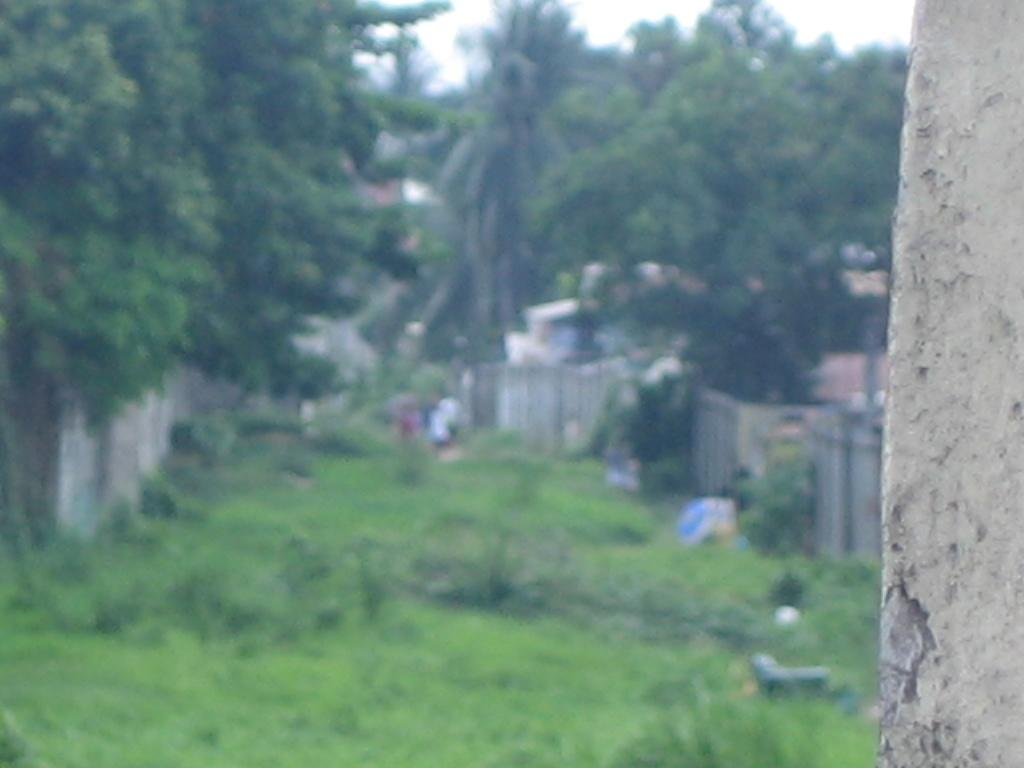What is the main subject in the foreground of the image? There is a tree trunk in the foreground of the image. What can be seen in the background of the image? There are trees, grass, a wall, objects, houses, and the sky visible in the background of the image. Can you describe the vegetation in the image? There are trees in the foreground and background of the image, as well as grass in the background. What type of structures are visible in the background of the image? There are houses and a wall visible in the background of the image. What part of the natural environment is visible in the image? The sky is visible in the background of the image. What sound can be heard coming from the lumber in the image? There is no lumber present in the image, and therefore no sound can be heard from it. 